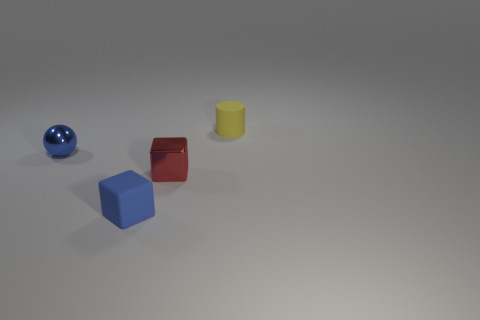How many metal things are large blue things or blue blocks?
Provide a short and direct response. 0. What is the color of the small thing that is both on the left side of the red metallic cube and in front of the sphere?
Your answer should be very brief. Blue. How many small red things are in front of the small blue shiny ball?
Ensure brevity in your answer.  1. What is the material of the tiny blue cube?
Ensure brevity in your answer.  Rubber. There is a small rubber object that is to the left of the tiny matte thing behind the matte thing that is left of the tiny cylinder; what color is it?
Keep it short and to the point. Blue. What number of blue blocks are the same size as the yellow rubber cylinder?
Offer a terse response. 1. What is the color of the tiny rubber thing behind the blue ball?
Offer a terse response. Yellow. What number of other things are the same size as the red block?
Give a very brief answer. 3. There is a object that is left of the yellow matte cylinder and to the right of the small matte block; what size is it?
Offer a terse response. Small. There is a tiny matte block; does it have the same color as the shiny thing behind the red cube?
Make the answer very short. Yes. 